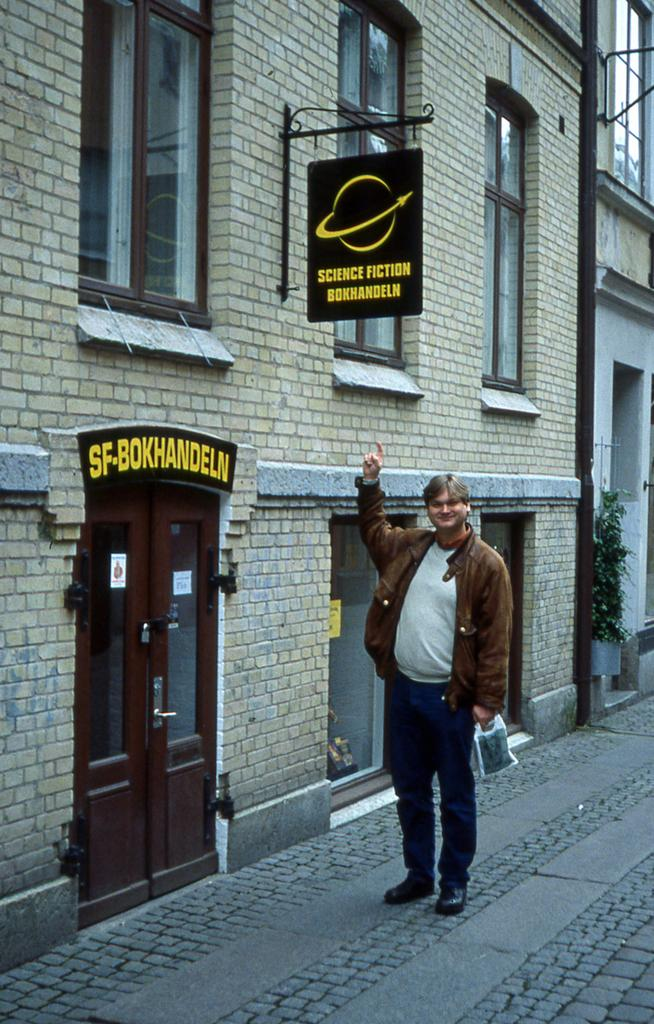What is the person in the image doing? The person is standing on the road in the image. What is behind the person in the image? The person is in front of a building. What features can be seen on the building? The building has windows. What other objects can be seen in the image? There is a board, a door, and a houseplant in the image. Where was the image taken? The image appears to be taken on the road. What type of zipper can be seen on the cave in the image? There is no cave or zipper present in the image. What is the cause of the person's action in the image? The provided facts do not give any information about the person's motivation or cause for standing on the road. 